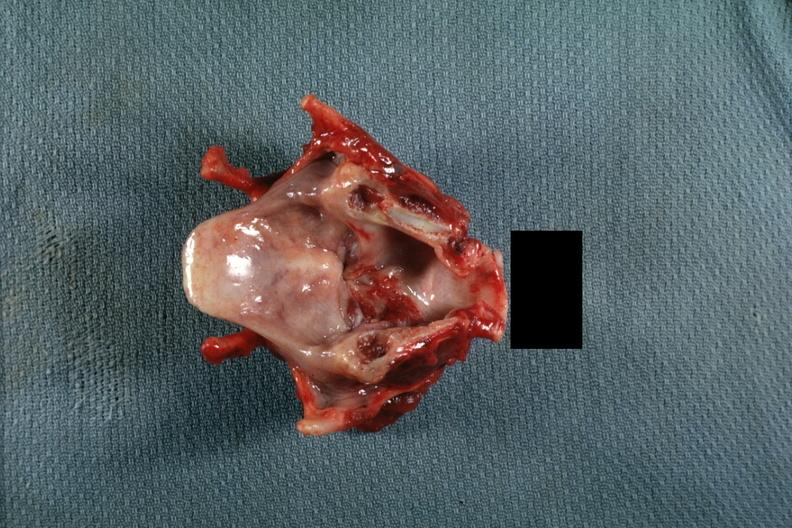what is present?
Answer the question using a single word or phrase. Carcinoma 